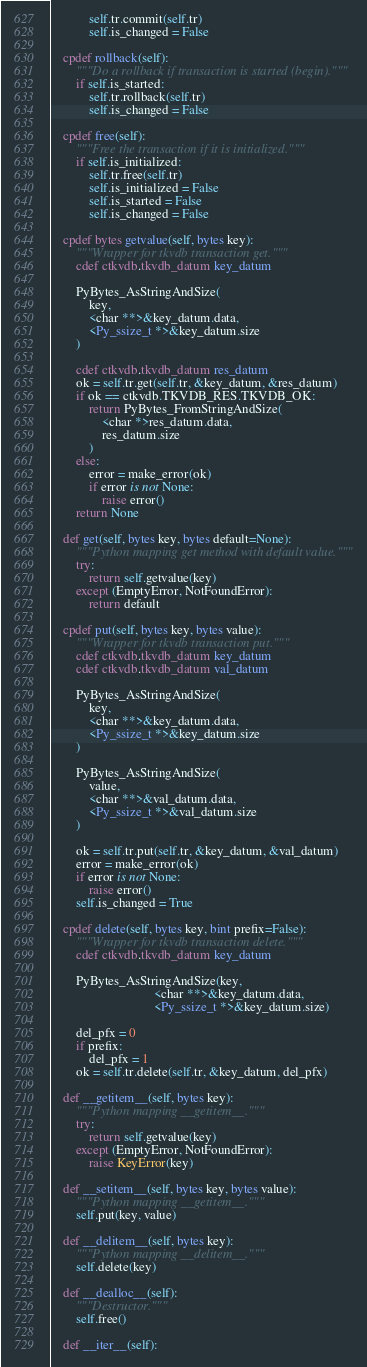<code> <loc_0><loc_0><loc_500><loc_500><_Cython_>            self.tr.commit(self.tr)
            self.is_changed = False

    cpdef rollback(self):
        """Do a rollback if transaction is started (begin)."""
        if self.is_started:
            self.tr.rollback(self.tr)
            self.is_changed = False

    cpdef free(self):
        """Free the transaction if it is initialized."""
        if self.is_initialized:
            self.tr.free(self.tr)
            self.is_initialized = False
            self.is_started = False
            self.is_changed = False

    cpdef bytes getvalue(self, bytes key):
        """Wrapper for tkvdb transaction get."""
        cdef ctkvdb.tkvdb_datum key_datum

        PyBytes_AsStringAndSize(
            key,
            <char **>&key_datum.data,
            <Py_ssize_t *>&key_datum.size
        )

        cdef ctkvdb.tkvdb_datum res_datum
        ok = self.tr.get(self.tr, &key_datum, &res_datum)
        if ok == ctkvdb.TKVDB_RES.TKVDB_OK:
            return PyBytes_FromStringAndSize(
                <char *>res_datum.data,
                res_datum.size
            )
        else:
            error = make_error(ok)
            if error is not None:
                raise error()
        return None

    def get(self, bytes key, bytes default=None):
        """Python mapping get method with default value."""
        try:
            return self.getvalue(key)
        except (EmptyError, NotFoundError):
            return default

    cpdef put(self, bytes key, bytes value):
        """Wrapper for tkvdb transaction put."""
        cdef ctkvdb.tkvdb_datum key_datum
        cdef ctkvdb.tkvdb_datum val_datum

        PyBytes_AsStringAndSize(
            key,
            <char **>&key_datum.data,
            <Py_ssize_t *>&key_datum.size
        )

        PyBytes_AsStringAndSize(
            value,
            <char **>&val_datum.data,
            <Py_ssize_t *>&val_datum.size
        )

        ok = self.tr.put(self.tr, &key_datum, &val_datum)
        error = make_error(ok)
        if error is not None:
            raise error()
        self.is_changed = True

    cpdef delete(self, bytes key, bint prefix=False):
        """Wrapper for tkvdb transaction delete."""
        cdef ctkvdb.tkvdb_datum key_datum

        PyBytes_AsStringAndSize(key,
                                <char **>&key_datum.data,
                                <Py_ssize_t *>&key_datum.size)

        del_pfx = 0
        if prefix:
            del_pfx = 1
        ok = self.tr.delete(self.tr, &key_datum, del_pfx)

    def __getitem__(self, bytes key):
        """Python mapping __getitem__."""
        try:
            return self.getvalue(key)
        except (EmptyError, NotFoundError):
            raise KeyError(key)

    def __setitem__(self, bytes key, bytes value):
        """Python mapping __getitem__."""
        self.put(key, value)

    def __delitem__(self, bytes key):
        """Python mapping __delitem__."""
        self.delete(key)

    def __dealloc__(self):
        """Destructor."""
        self.free()

    def __iter__(self):</code> 